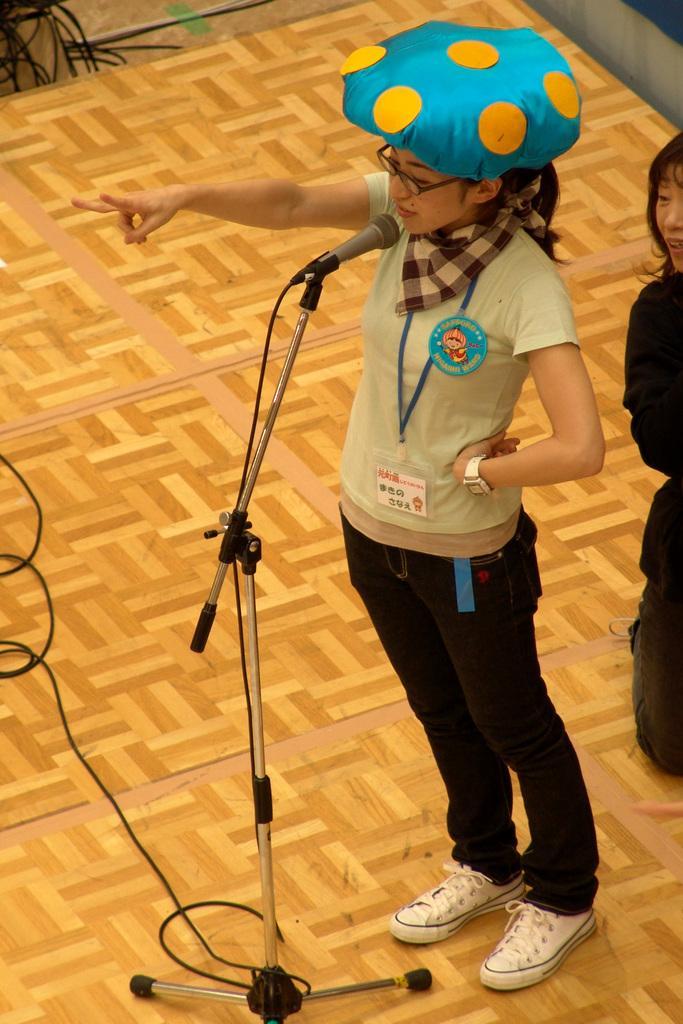Could you give a brief overview of what you see in this image? This image consists of a girl talking in the mic. She is wearing a cap and white shoes. At the bottom, there is floor. To the top left, there are wires. Behind her there is another girl sitting on the knees. 